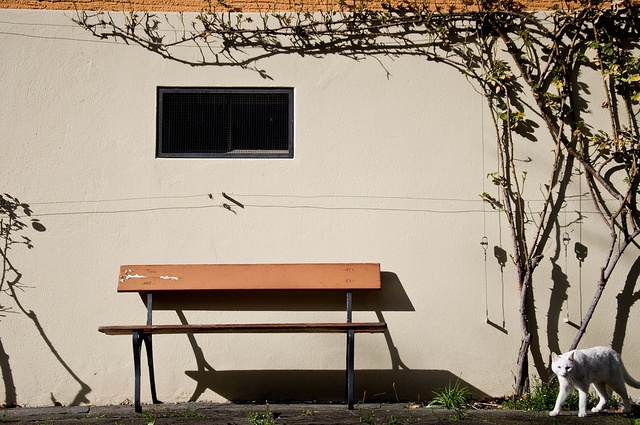Describe the objects in this image and their specific colors. I can see bench in brown, black, salmon, and lightgray tones and cat in gray, black, lightgray, and darkgray tones in this image. 